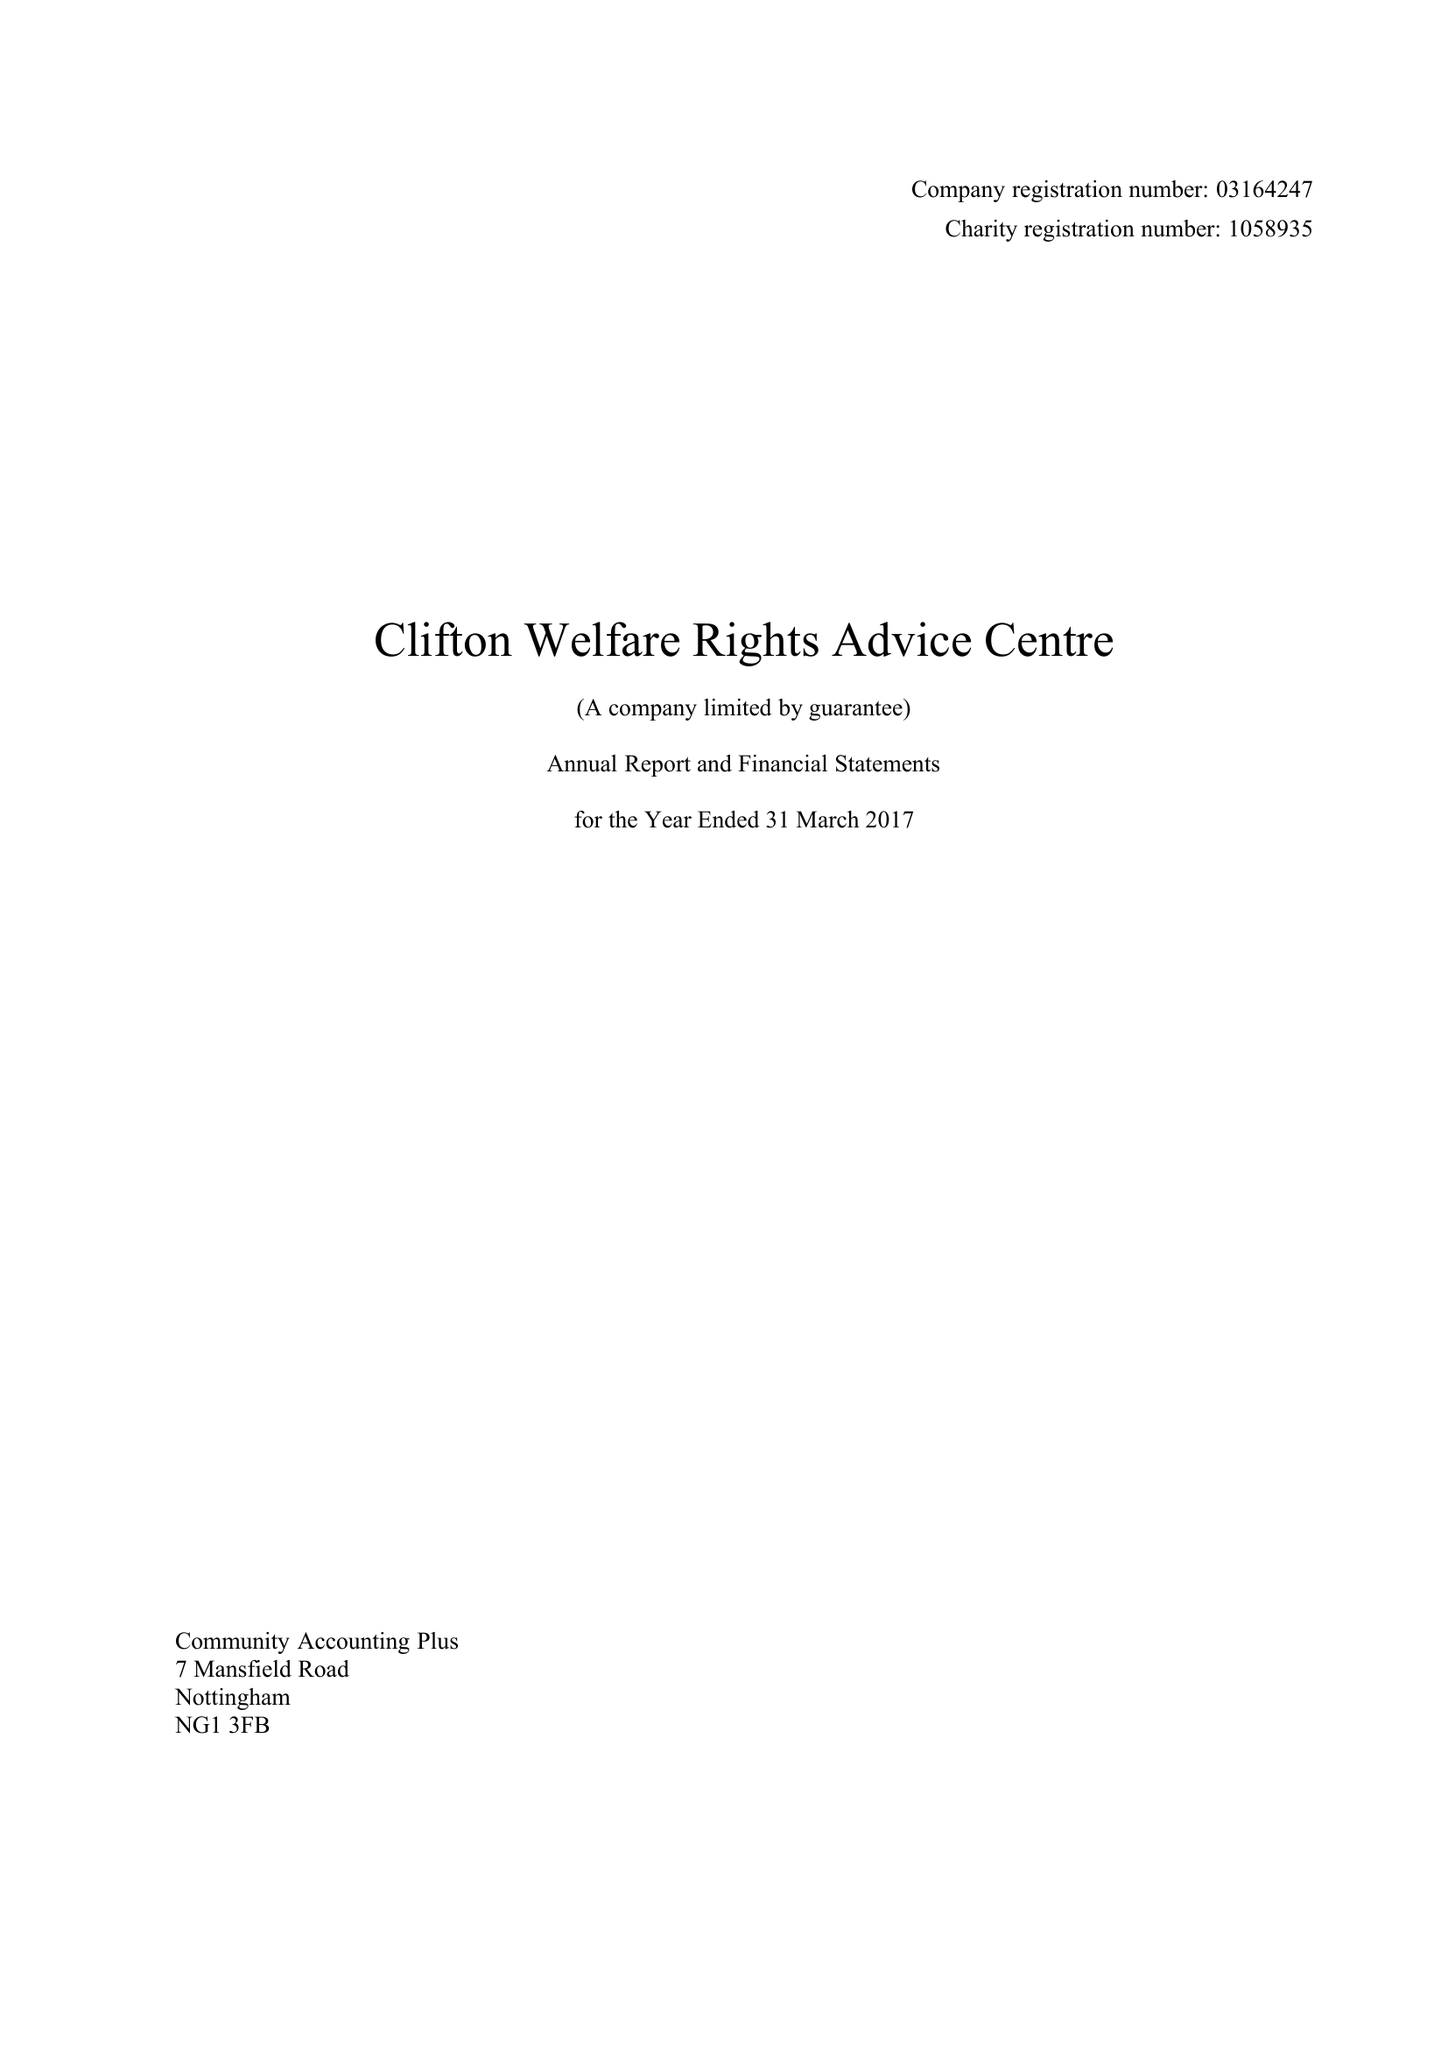What is the value for the income_annually_in_british_pounds?
Answer the question using a single word or phrase. 79371.00 